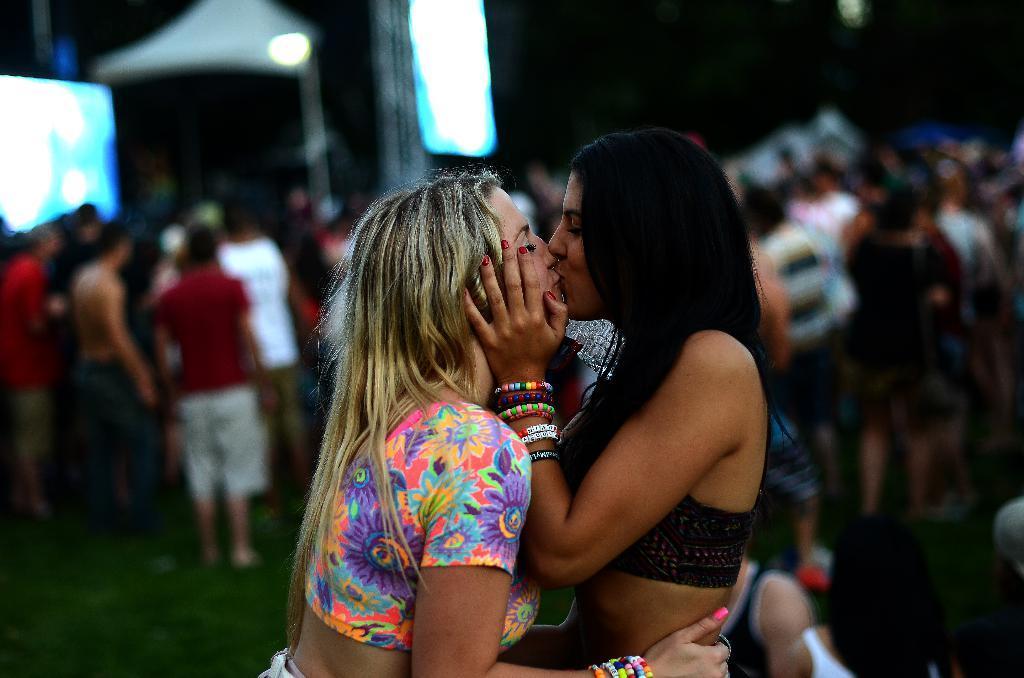Please provide a concise description of this image. In this picture there are two women kissing each other. In the background of the image it is blurry and we can see people and objects. 